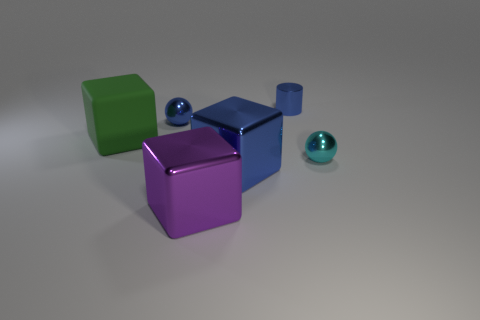Subtract all large blue shiny blocks. How many blocks are left? 2 Add 4 cylinders. How many objects exist? 10 Subtract 1 blocks. How many blocks are left? 2 Subtract all green blocks. How many blocks are left? 2 Subtract all cylinders. How many objects are left? 5 Subtract all tiny cyan rubber blocks. Subtract all purple shiny cubes. How many objects are left? 5 Add 6 tiny things. How many tiny things are left? 9 Add 4 small blue balls. How many small blue balls exist? 5 Subtract 0 gray blocks. How many objects are left? 6 Subtract all cyan spheres. Subtract all blue cubes. How many spheres are left? 1 